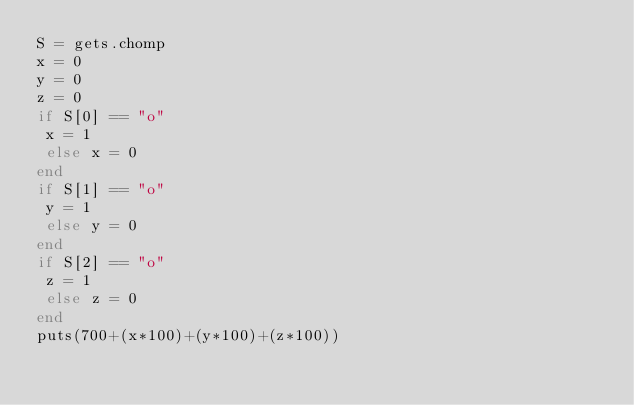<code> <loc_0><loc_0><loc_500><loc_500><_Ruby_>S = gets.chomp
x = 0
y = 0
z = 0
if S[0] == "o"
 x = 1
 else x = 0
end
if S[1] == "o"
 y = 1
 else y = 0
end
if S[2] == "o"
 z = 1
 else z = 0
end
puts(700+(x*100)+(y*100)+(z*100))</code> 